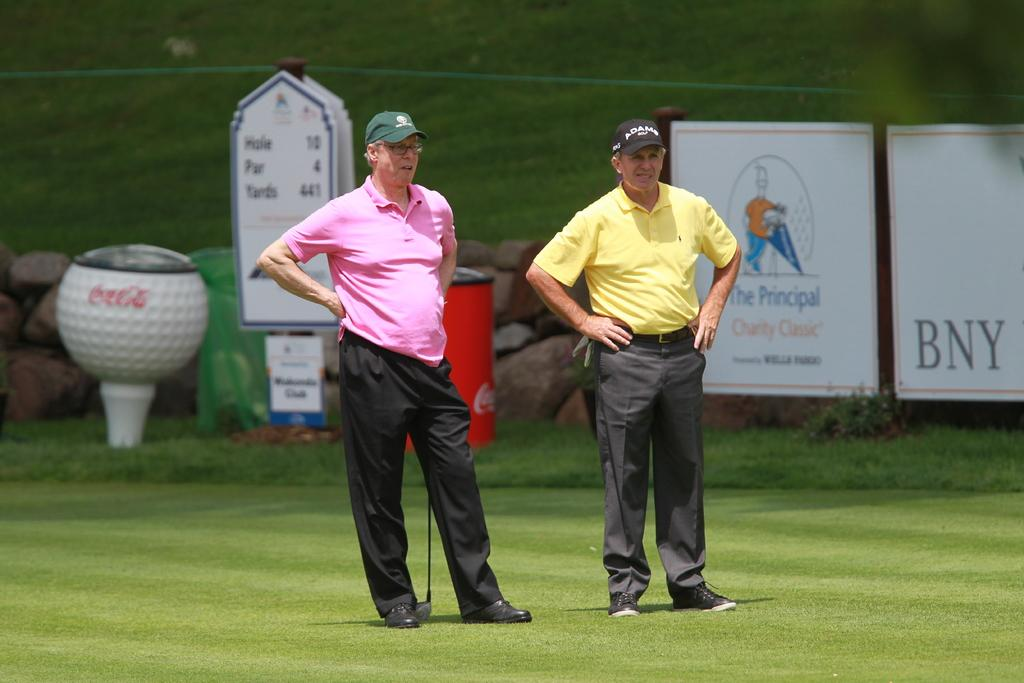<image>
Write a terse but informative summary of the picture. two men on the golf course for the event the principal charity classic 